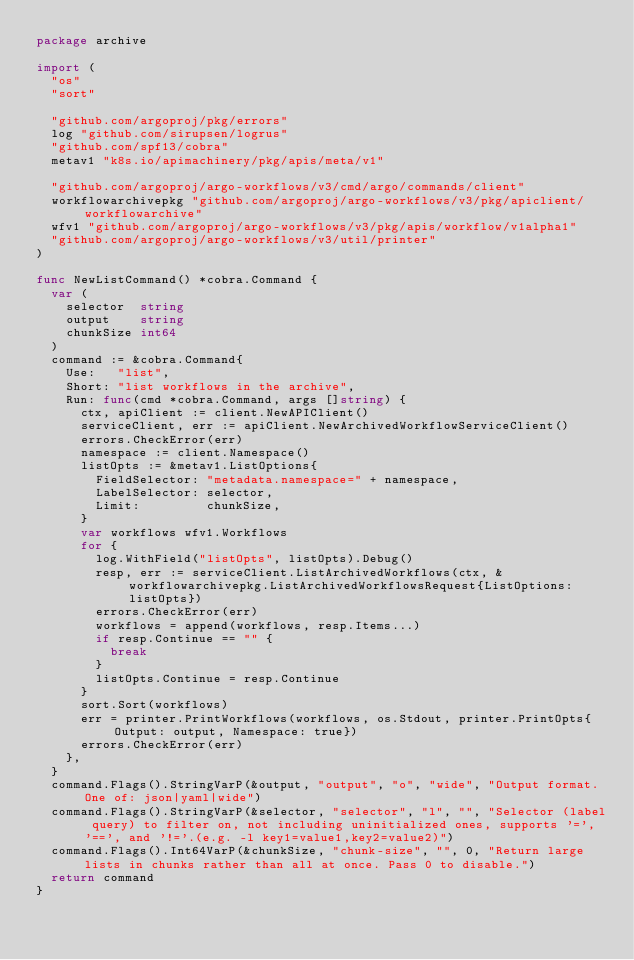<code> <loc_0><loc_0><loc_500><loc_500><_Go_>package archive

import (
	"os"
	"sort"

	"github.com/argoproj/pkg/errors"
	log "github.com/sirupsen/logrus"
	"github.com/spf13/cobra"
	metav1 "k8s.io/apimachinery/pkg/apis/meta/v1"

	"github.com/argoproj/argo-workflows/v3/cmd/argo/commands/client"
	workflowarchivepkg "github.com/argoproj/argo-workflows/v3/pkg/apiclient/workflowarchive"
	wfv1 "github.com/argoproj/argo-workflows/v3/pkg/apis/workflow/v1alpha1"
	"github.com/argoproj/argo-workflows/v3/util/printer"
)

func NewListCommand() *cobra.Command {
	var (
		selector  string
		output    string
		chunkSize int64
	)
	command := &cobra.Command{
		Use:   "list",
		Short: "list workflows in the archive",
		Run: func(cmd *cobra.Command, args []string) {
			ctx, apiClient := client.NewAPIClient()
			serviceClient, err := apiClient.NewArchivedWorkflowServiceClient()
			errors.CheckError(err)
			namespace := client.Namespace()
			listOpts := &metav1.ListOptions{
				FieldSelector: "metadata.namespace=" + namespace,
				LabelSelector: selector,
				Limit:         chunkSize,
			}
			var workflows wfv1.Workflows
			for {
				log.WithField("listOpts", listOpts).Debug()
				resp, err := serviceClient.ListArchivedWorkflows(ctx, &workflowarchivepkg.ListArchivedWorkflowsRequest{ListOptions: listOpts})
				errors.CheckError(err)
				workflows = append(workflows, resp.Items...)
				if resp.Continue == "" {
					break
				}
				listOpts.Continue = resp.Continue
			}
			sort.Sort(workflows)
			err = printer.PrintWorkflows(workflows, os.Stdout, printer.PrintOpts{Output: output, Namespace: true})
			errors.CheckError(err)
		},
	}
	command.Flags().StringVarP(&output, "output", "o", "wide", "Output format. One of: json|yaml|wide")
	command.Flags().StringVarP(&selector, "selector", "l", "", "Selector (label query) to filter on, not including uninitialized ones, supports '=', '==', and '!='.(e.g. -l key1=value1,key2=value2)")
	command.Flags().Int64VarP(&chunkSize, "chunk-size", "", 0, "Return large lists in chunks rather than all at once. Pass 0 to disable.")
	return command
}
</code> 